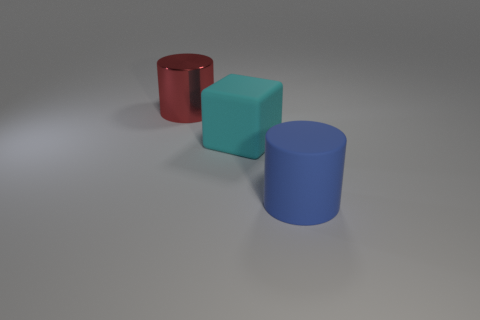Add 1 small green rubber cylinders. How many objects exist? 4 Subtract all cubes. How many objects are left? 2 Add 2 large cyan blocks. How many large cyan blocks exist? 3 Subtract 0 blue balls. How many objects are left? 3 Subtract all big cyan objects. Subtract all cyan matte cubes. How many objects are left? 1 Add 3 blocks. How many blocks are left? 4 